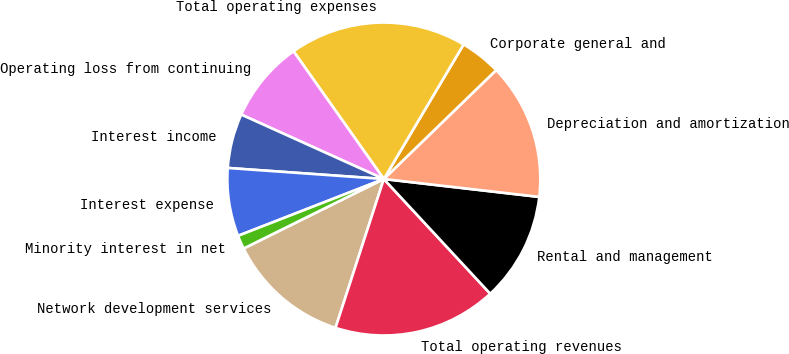<chart> <loc_0><loc_0><loc_500><loc_500><pie_chart><fcel>Network development services<fcel>Total operating revenues<fcel>Rental and management<fcel>Depreciation and amortization<fcel>Corporate general and<fcel>Total operating expenses<fcel>Operating loss from continuing<fcel>Interest income<fcel>Interest expense<fcel>Minority interest in net<nl><fcel>12.68%<fcel>16.9%<fcel>11.27%<fcel>14.08%<fcel>4.23%<fcel>18.31%<fcel>8.45%<fcel>5.63%<fcel>7.04%<fcel>1.41%<nl></chart> 